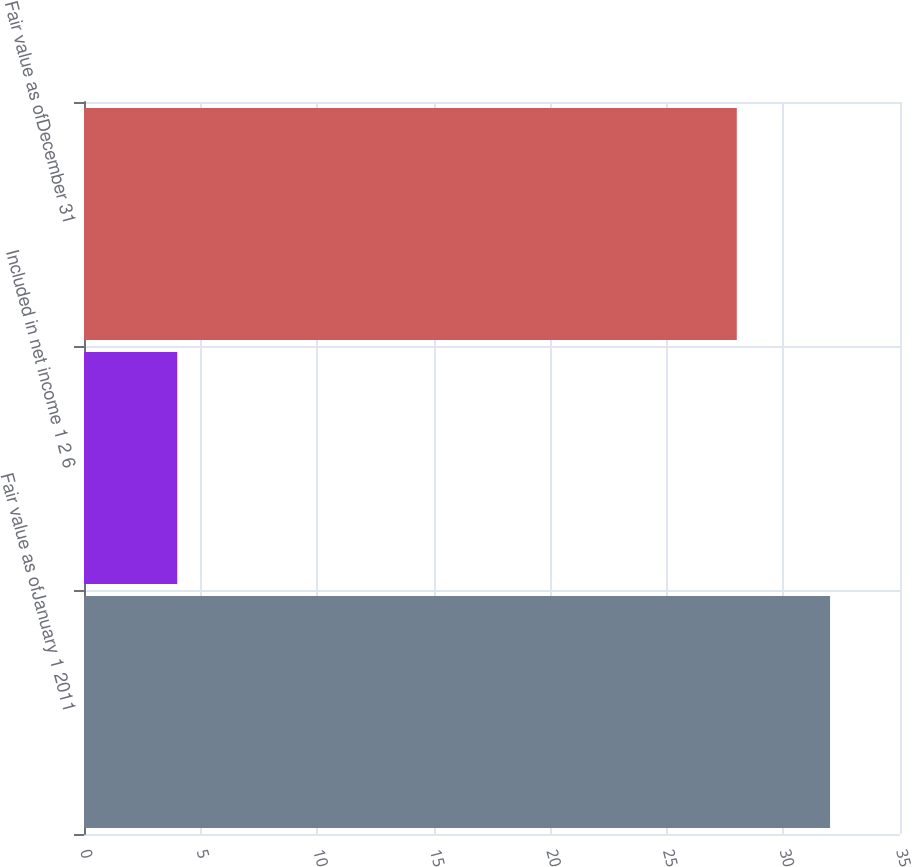Convert chart. <chart><loc_0><loc_0><loc_500><loc_500><bar_chart><fcel>Fair value as ofJanuary 1 2011<fcel>Included in net income 1 2 6<fcel>Fair value as ofDecember 31<nl><fcel>32<fcel>4<fcel>28<nl></chart> 